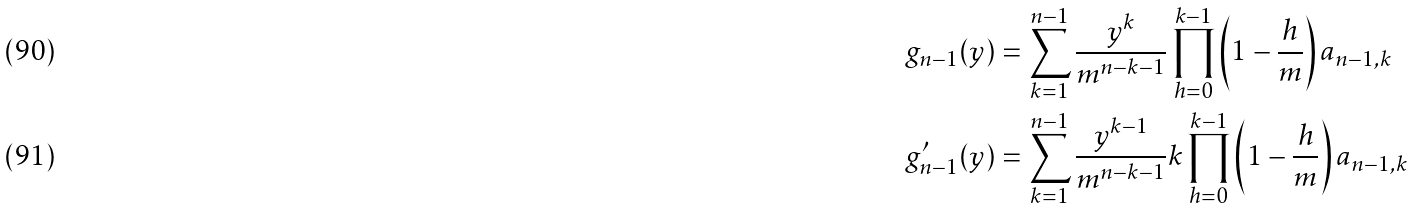<formula> <loc_0><loc_0><loc_500><loc_500>& g _ { n - 1 } ( y ) = \sum _ { k = 1 } ^ { n - 1 } \frac { y ^ { k } } { m ^ { n - k - 1 } } \prod _ { h = 0 } ^ { k - 1 } \left ( 1 - \frac { h } { m } \right ) a _ { n - 1 , k } \\ & g ^ { \prime } _ { n - 1 } ( y ) = \sum _ { k = 1 } ^ { n - 1 } \frac { y ^ { k - 1 } } { m ^ { n - k - 1 } } k \prod _ { h = 0 } ^ { k - 1 } \left ( 1 - \frac { h } { m } \right ) a _ { n - 1 , k }</formula> 